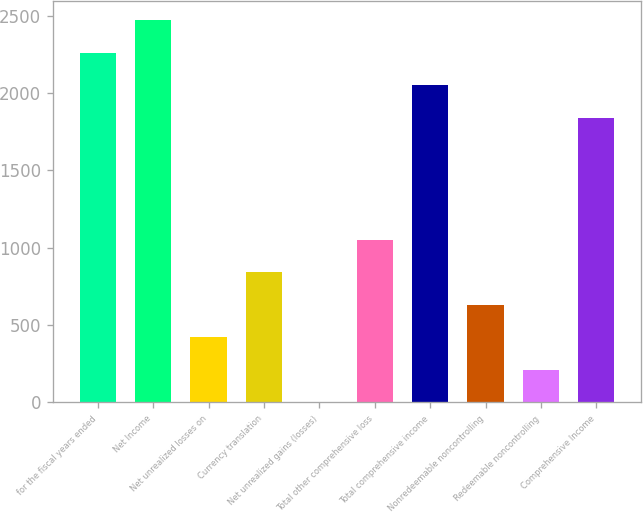<chart> <loc_0><loc_0><loc_500><loc_500><bar_chart><fcel>for the fiscal years ended<fcel>Net Income<fcel>Net unrealized losses on<fcel>Currency translation<fcel>Net unrealized gains (losses)<fcel>Total other comprehensive loss<fcel>Total comprehensive income<fcel>Nonredeemable noncontrolling<fcel>Redeemable noncontrolling<fcel>Comprehensive Income<nl><fcel>2259.62<fcel>2470.03<fcel>421.42<fcel>842.24<fcel>0.6<fcel>1052.65<fcel>2049.21<fcel>631.83<fcel>211.01<fcel>1838.8<nl></chart> 